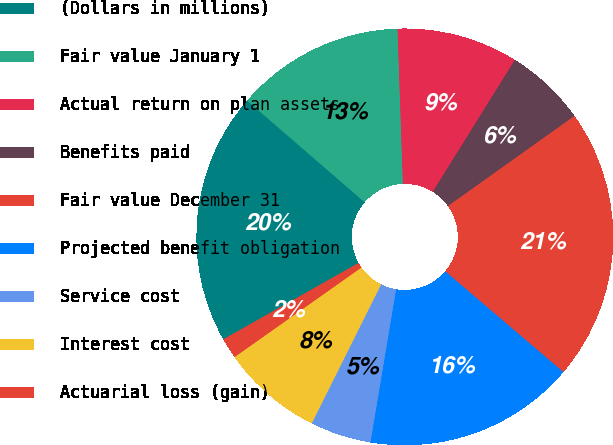<chart> <loc_0><loc_0><loc_500><loc_500><pie_chart><fcel>(Dollars in millions)<fcel>Fair value January 1<fcel>Actual return on plan assets<fcel>Benefits paid<fcel>Fair value December 31<fcel>Projected benefit obligation<fcel>Service cost<fcel>Interest cost<fcel>Actuarial loss (gain)<nl><fcel>19.53%<fcel>13.1%<fcel>9.41%<fcel>6.29%<fcel>21.09%<fcel>16.4%<fcel>4.73%<fcel>7.85%<fcel>1.6%<nl></chart> 